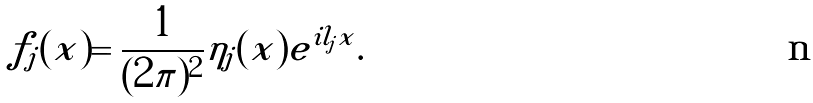<formula> <loc_0><loc_0><loc_500><loc_500>f _ { j } ( x ) = \frac { 1 } { ( 2 \pi ) ^ { 2 } } \eta _ { j } ( x ) e ^ { i l _ { j } x } .</formula> 